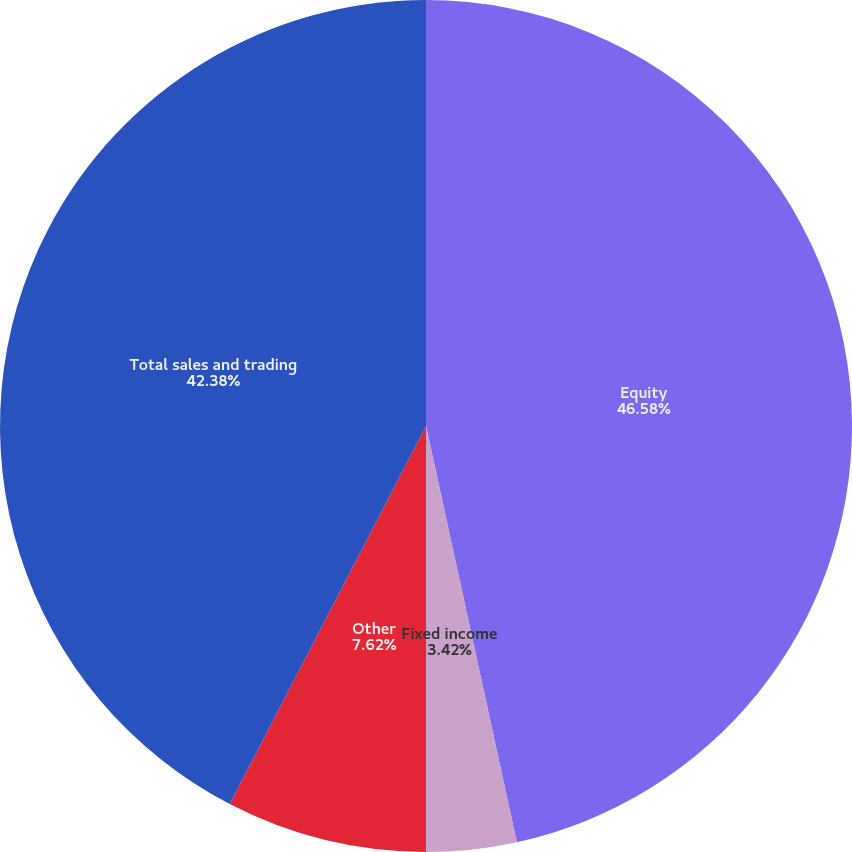Convert chart to OTSL. <chart><loc_0><loc_0><loc_500><loc_500><pie_chart><fcel>Equity<fcel>Fixed income<fcel>Other<fcel>Total sales and trading<nl><fcel>46.58%<fcel>3.42%<fcel>7.62%<fcel>42.38%<nl></chart> 